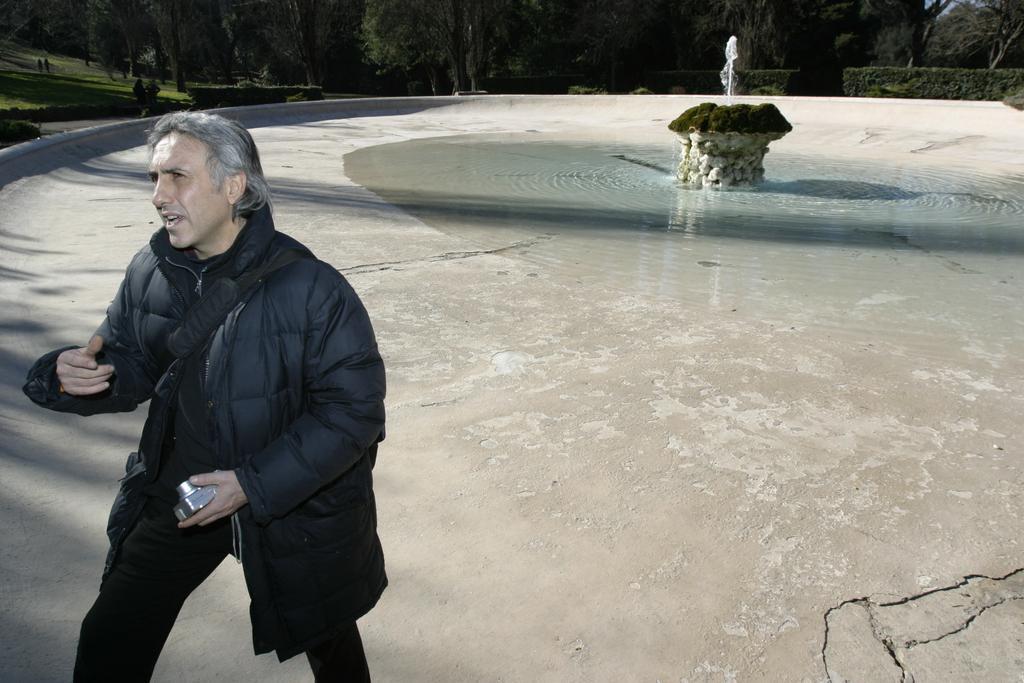How would you summarize this image in a sentence or two? In this image we can see there are people standing on the ground and holding a camera. And there is a fountain with grass and water on the ground. At the back there are trees. 